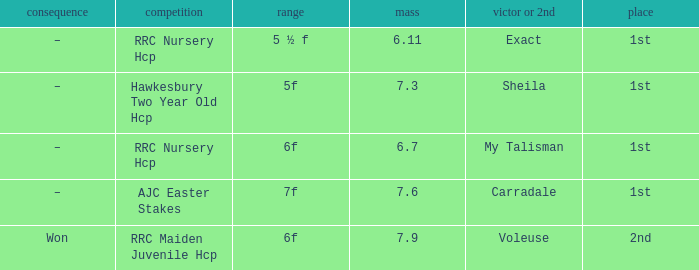What is the largest weight wth a Result of –, and a Distance of 7f? 7.6. 